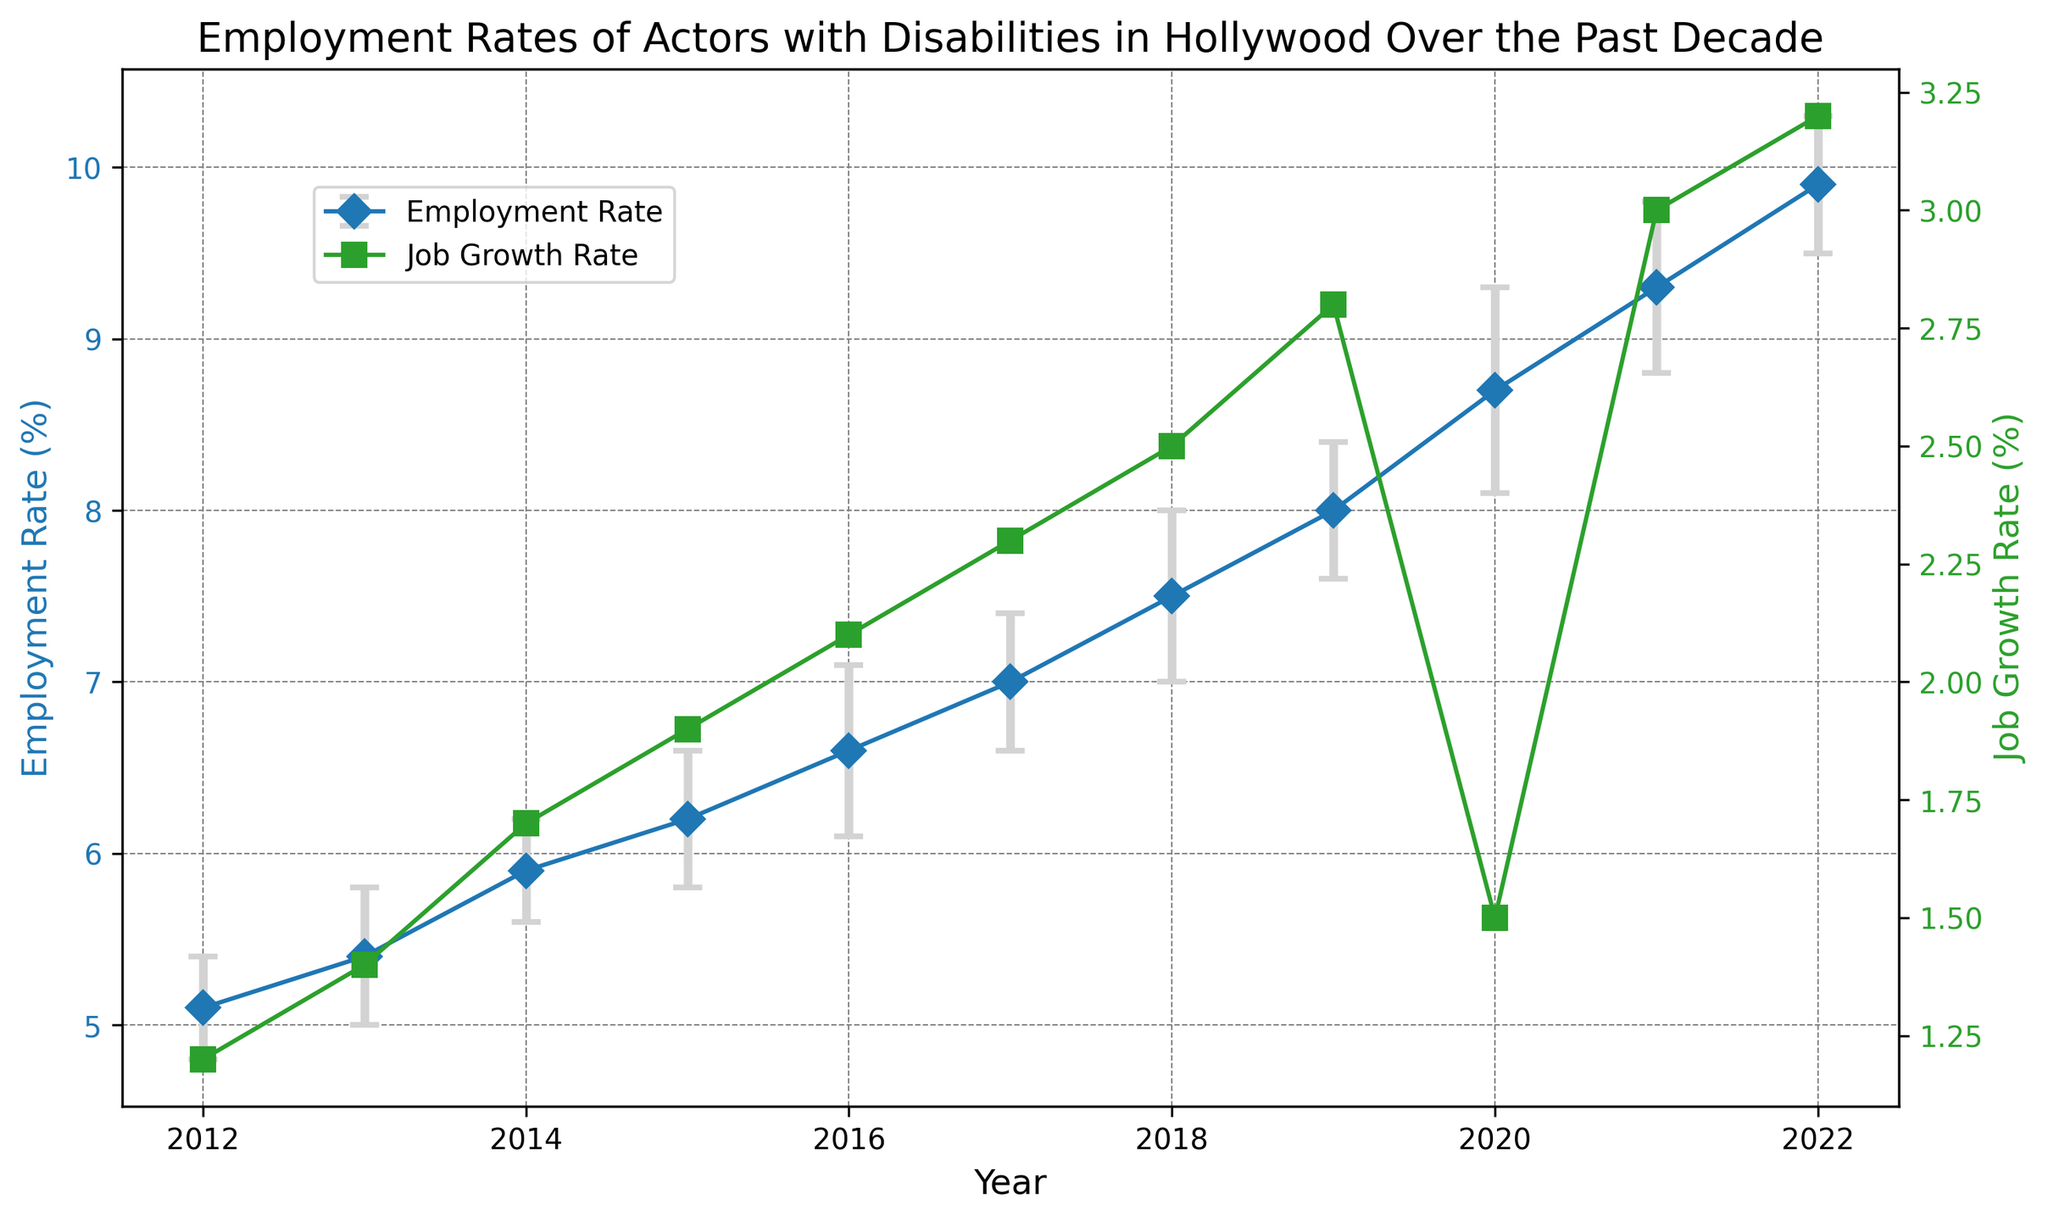How did the employment rate change between 2012 and 2022? The employment rate increased from 5.1% in 2012 to 9.9% in 2022. To find the change, subtract the employment rate in 2012 from the rate in 2022. So, the change is 9.9% - 5.1% = 4.8%.
Answer: 4.8% What was the job growth rate in 2016 and how does it compare to the rate in 2020? The job growth rate in 2016 was 2.1%, while in 2020 it was 1.5%. Compare these values to see that the 2016 rate was higher.
Answer: 2016 was higher Which year had the highest employment rate, and what was the rate? By observing the plot, you can see that 2022 had the highest employment rate at 9.9%.
Answer: 2022, 9.9% What was the lowest job growth rate observed and in which year did it occur? By examining the job growth rate line, the lowest rate was 1.2% in 2012.
Answer: 1.2%, 2012 In which year did the employment rate increase the most compared to the previous year? To find the highest increase, calculate the rate differences year-over-year and identify the biggest change. The increase from 2019 to 2020 (8.0% to 8.7%) is 0.7%, the largest single-year increment.
Answer: 2020 Calculate the average employment rate from 2012 to 2022. Add all employment rates from 2012 to 2022 and divide by the number of years: (5.1 + 5.4 + 5.9 + 6.2 + 6.6 + 7.0 + 7.5 + 8.0 + 8.7 + 9.3 + 9.9) / 11 = 7.09%.
Answer: 7.09% What is the employment rate trend from 2012 to 2022: increasing, decreasing, or constant? Observing the plot, the employment rate steadily increases each year from 2012 to 2022.
Answer: Increasing How did the job growth rate change from 2019 to 2020 and what might be a significant reason for this change? The job growth rate decreased from 2.8% in 2019 to 1.5% in 2020, likely due to the impact of the COVID-19 pandemic on the film industry.
Answer: Decreased, COVID-19 pandemic Describe the error bars' trend in the employment rates from 2012 to 2022. The error bars mostly increase in size from 2012, peaking around 2020, then decrease again slightly, indicating more variability in the middle of the decade compared to the start and end.
Answer: Increasing then decreasing 